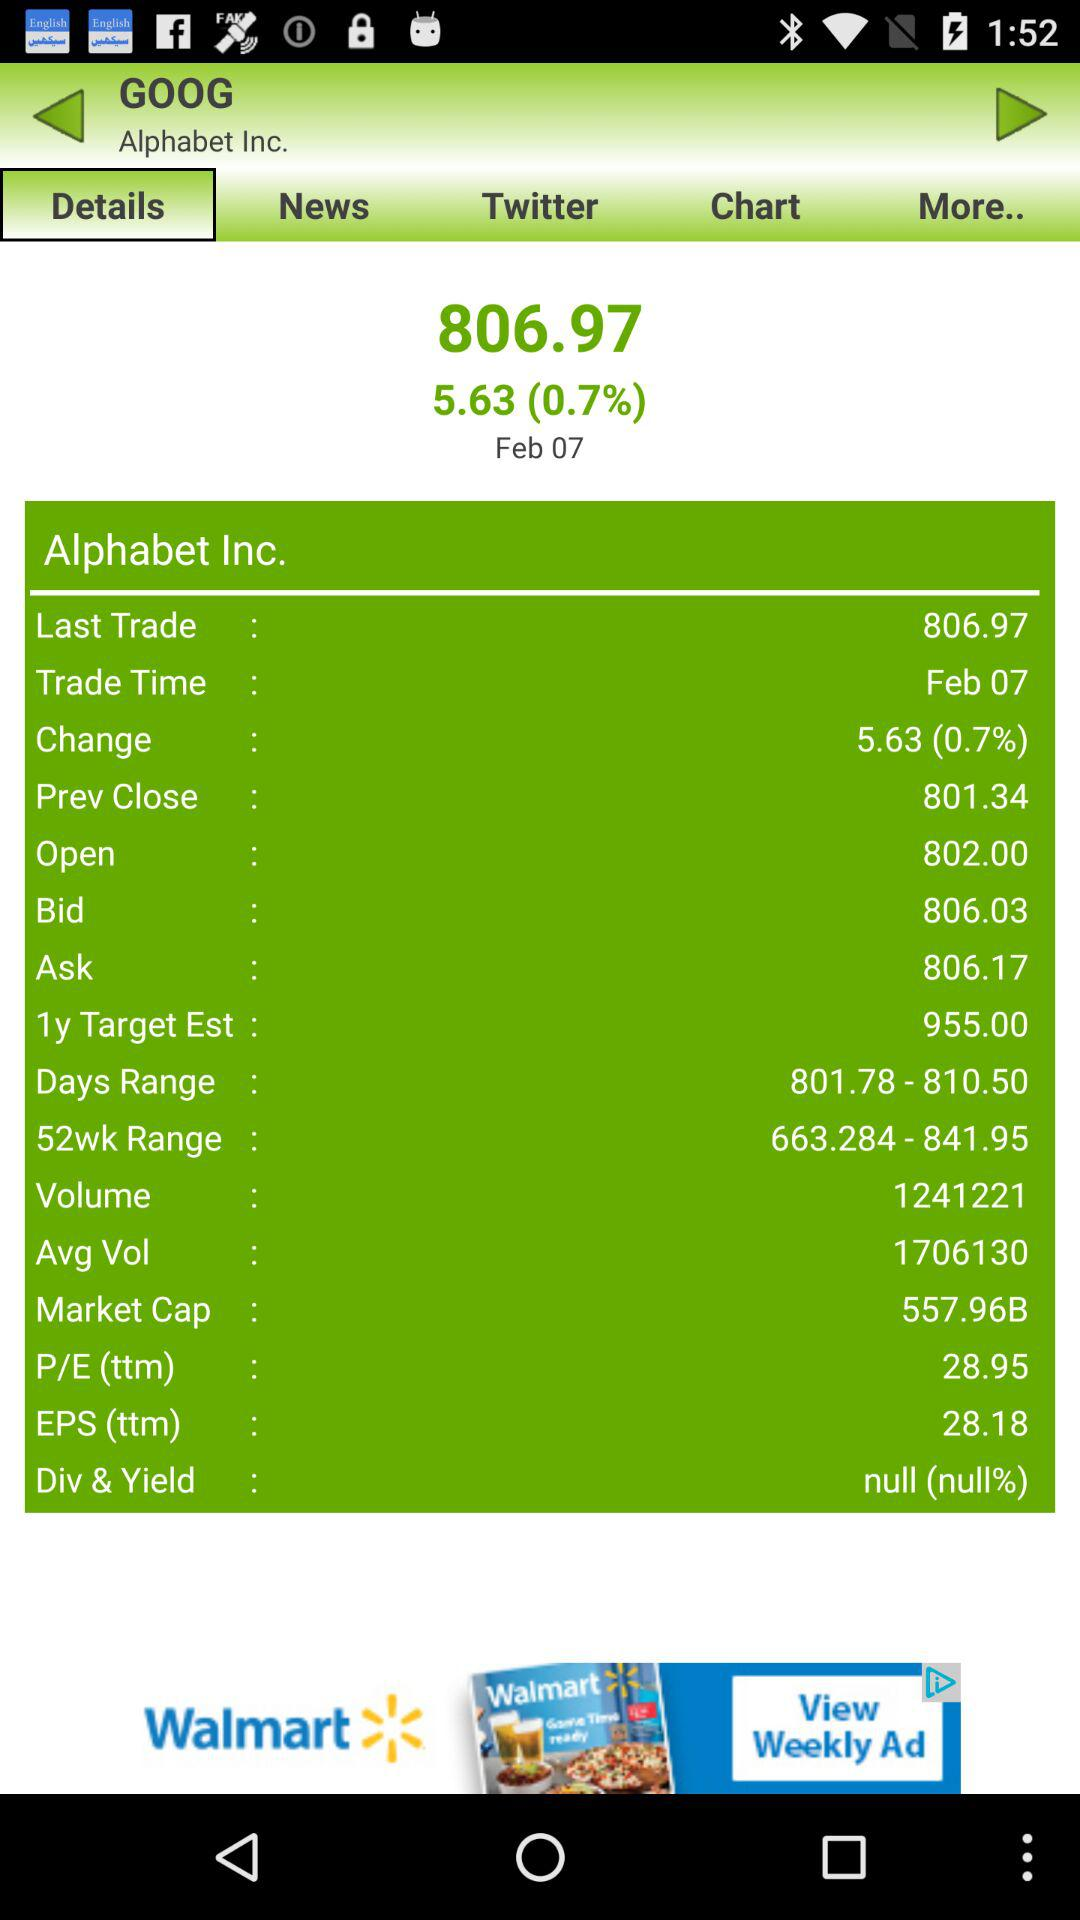What is the last traded price of "Alphabet Inc."? The last traded price of "Alphabet Inc." is 806.97. 